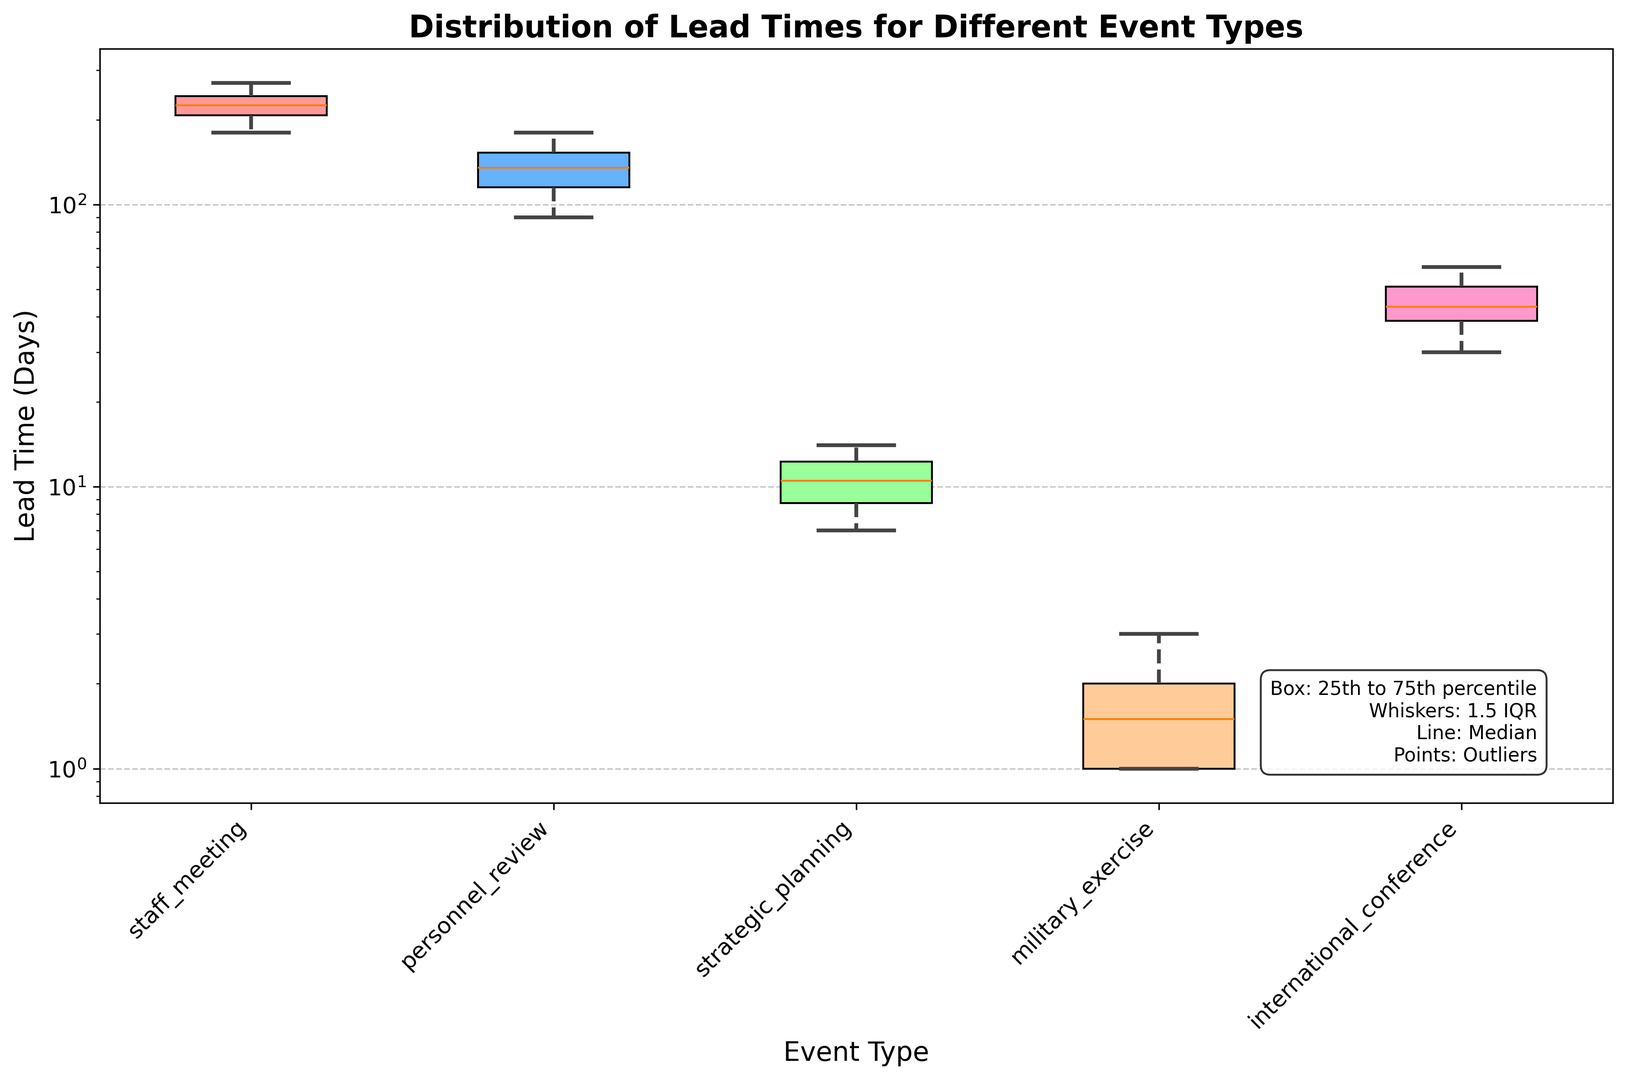What is the median lead time for scheduling a personnel review? To find the median lead time for scheduling a personnel review, identify the middle value of the personnel review group's lead times. As there are 8 data points, the median is the average of the 4th and 5th values when sorted in ascending order. From the figure, the median appears to be around 10 or 11 days.
Answer: 10 or 11 days Which event type has the highest median lead time? To determine the event type with the highest median lead time, visually inspect the box plot and identify the event type where the central line (median) is at the highest position on the y-axis. From the figure, it appears that 'international_conference' has the highest median lead time.
Answer: International conference How does the spread (interquartile range) of lead times for military exercises compare to that of strategic planning? To compare the spreads, examine the height of the boxes representing the interquartile ranges (IQR). The spread for 'military_exercise' appears larger than that of 'strategic_planning', as the box for military exercises is taller.
Answer: Military exercises have a larger spread Among the event types, which one exhibits the shortest lead times overall? To find the event type with the shortest overall lead times, look for the box plot positioned lowest on the y-axis. 'staff_meeting' has its entire box plot at the lowest position on the y-axis.
Answer: Staff meeting What are the approximate ranges of lead times for strategic planning and international conferences? Check the boxes and whiskers on the box plots for 'strategic_planning' and 'international_conference'. For strategic planning, the overall range appears to be from around 30 to 60 days. For international conferences, it spans approximately from 180 to 270 days.
Answer: Strategic planning: 30-60 days, International conference: 180-270 days Which event type has the most varied lead times, and how does this compare to the least varied event type? To determine the most varied and least varied lead times, look at the length of the whiskers and the size of the boxes. 'international_conference' has the most varied lead times, with a long range between the minimum and maximum. 'staff_meeting' has the least varied lead times, with a shorter range.
Answer: Most varied: International conference, Least varied: Staff meeting 